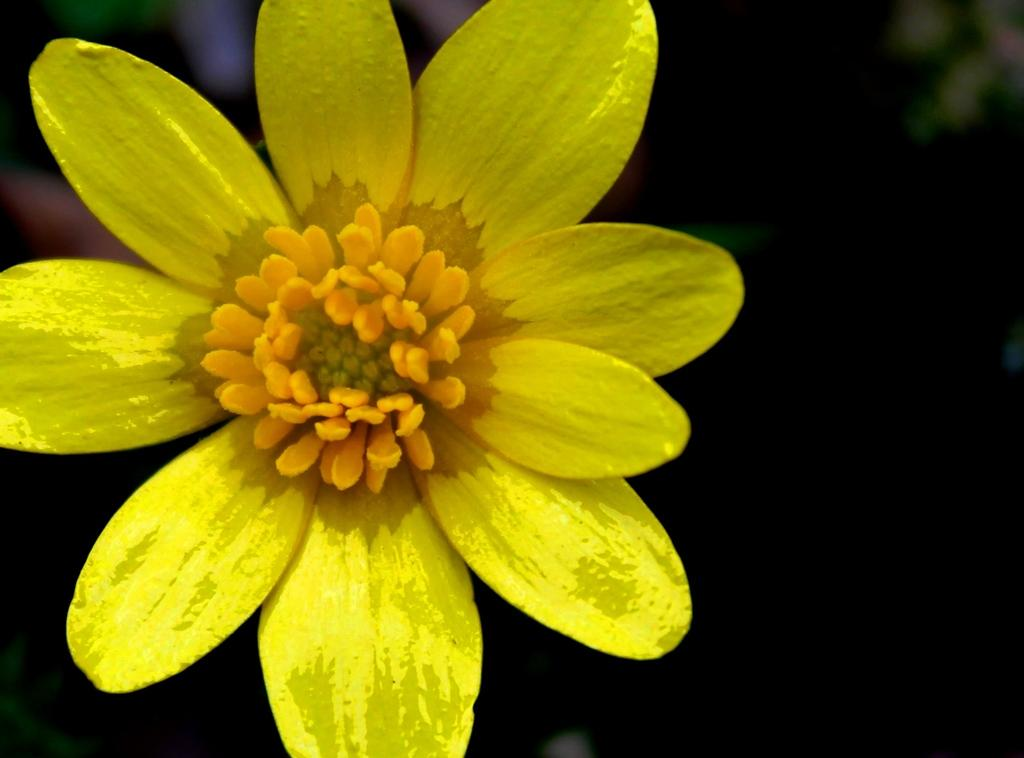What is the main subject of the image? There is a flower in the image. What color is the flower? The flower is yellow in color. What type of observation can be made about the floor in the image? There is no mention of a floor in the provided facts, so it is not possible to make any observations about it. 